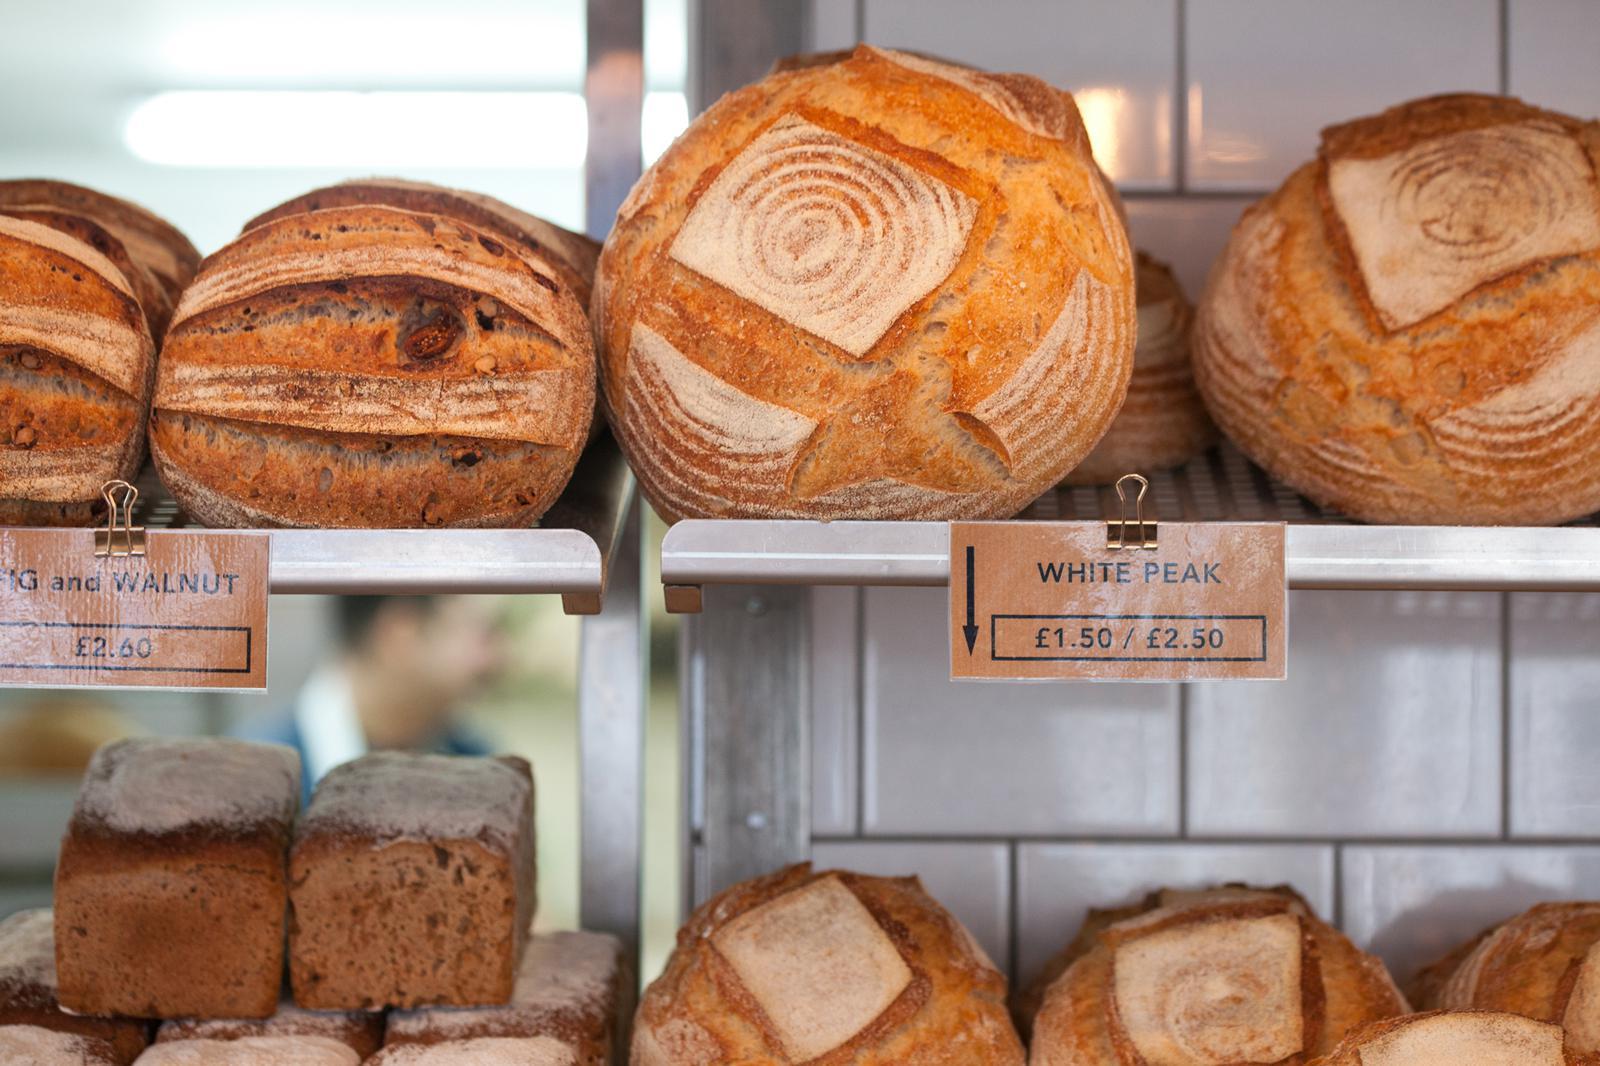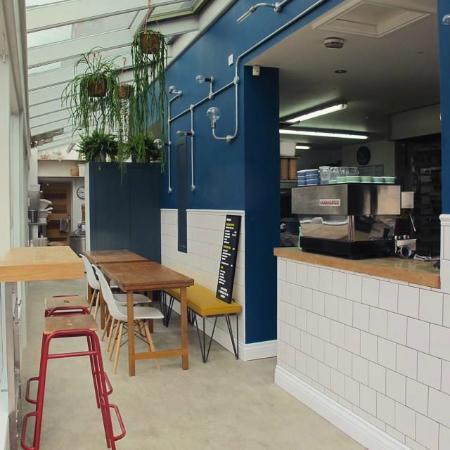The first image is the image on the left, the second image is the image on the right. Analyze the images presented: Is the assertion "An outside view of the Forge Bakehouse." valid? Answer yes or no. No. The first image is the image on the left, the second image is the image on the right. For the images displayed, is the sentence "Both images are of the outside of the store." factually correct? Answer yes or no. No. 